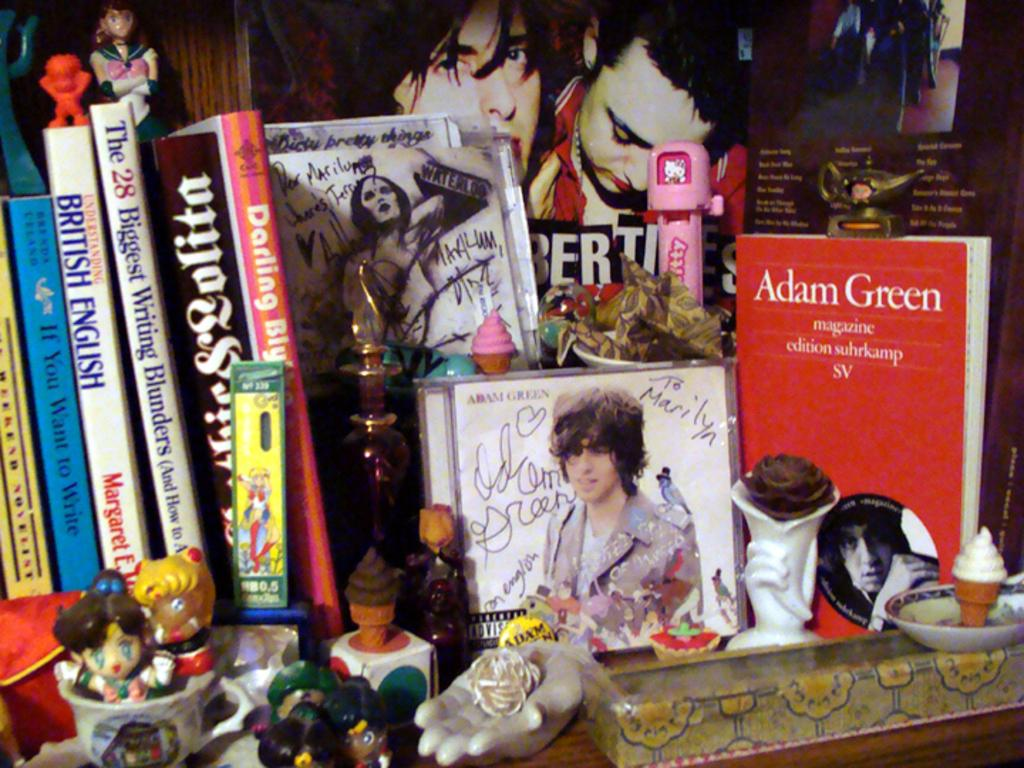<image>
Offer a succinct explanation of the picture presented. a red book by Adam Green among other novels with toy figurines. 